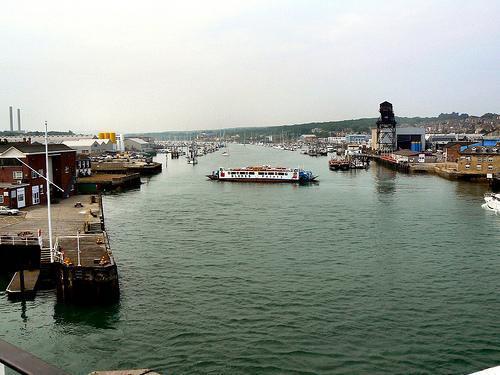How many barges are there?
Give a very brief answer. 1. 